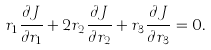<formula> <loc_0><loc_0><loc_500><loc_500>r _ { 1 } \frac { \partial J } { \partial r _ { 1 } } + 2 r _ { 2 } \frac { \partial J } { \partial r _ { 2 } } + r _ { 3 } \frac { \partial J } { \partial r _ { 3 } } = 0 .</formula> 